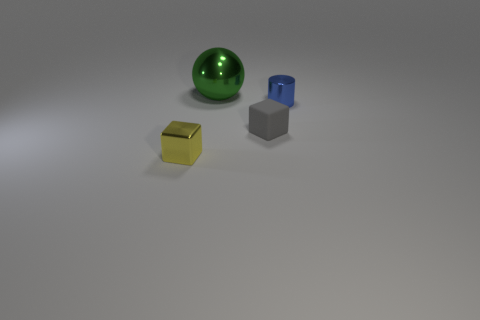Is there any other thing that has the same material as the yellow block?
Offer a terse response. Yes. Is the color of the thing to the right of the tiny rubber object the same as the big shiny sphere?
Your answer should be compact. No. How many red objects are tiny matte balls or small metal blocks?
Provide a short and direct response. 0. What number of other objects are there of the same shape as the blue metallic thing?
Provide a succinct answer. 0. Is the yellow block made of the same material as the large sphere?
Offer a terse response. Yes. What is the tiny object that is both to the left of the small metallic cylinder and on the right side of the metal cube made of?
Provide a short and direct response. Rubber. What color is the metal thing right of the green sphere?
Provide a short and direct response. Blue. Is the number of green balls in front of the shiny ball greater than the number of blue things?
Keep it short and to the point. No. How many other objects are the same size as the green object?
Your answer should be compact. 0. There is a small gray rubber thing; how many small yellow objects are behind it?
Offer a terse response. 0. 